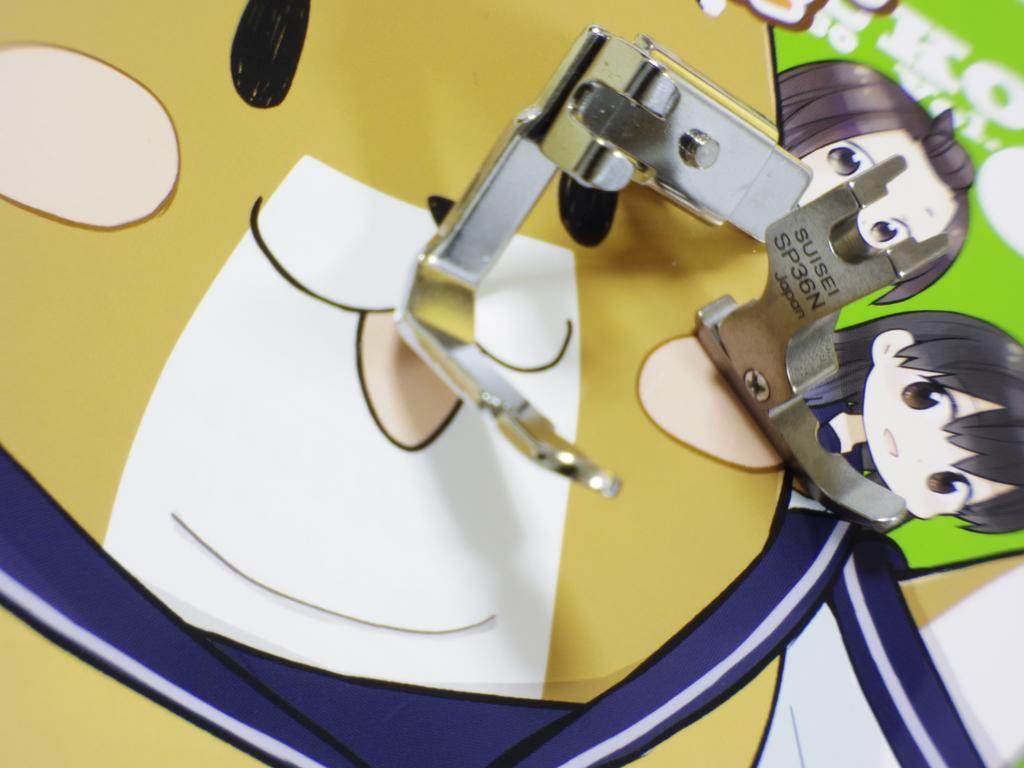How would you summarize this image in a sentence or two? In this image I see the pictures of cartoon characters and I see things over here which are of silver in color and I see something is written over here. 